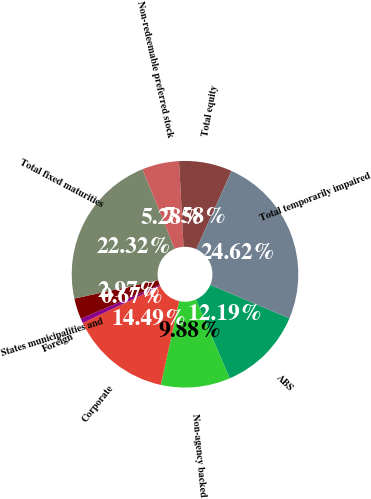Convert chart. <chart><loc_0><loc_0><loc_500><loc_500><pie_chart><fcel>ABS<fcel>Non-agency backed<fcel>Corporate<fcel>Foreign<fcel>States municipalities and<fcel>Total fixed maturities<fcel>Non-redeemable preferred stock<fcel>Total equity<fcel>Total temporarily impaired<nl><fcel>12.19%<fcel>9.88%<fcel>14.49%<fcel>0.67%<fcel>2.97%<fcel>22.32%<fcel>5.28%<fcel>7.58%<fcel>24.62%<nl></chart> 